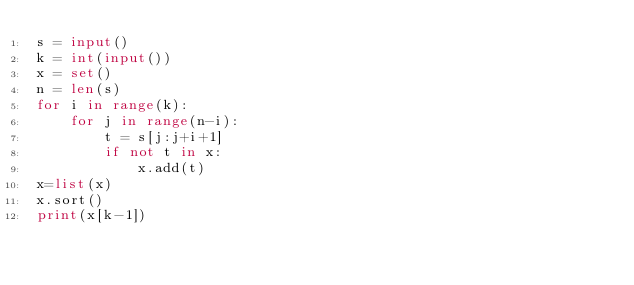<code> <loc_0><loc_0><loc_500><loc_500><_Python_>s = input()
k = int(input())
x = set()
n = len(s)
for i in range(k):
    for j in range(n-i):
        t = s[j:j+i+1]
        if not t in x:
            x.add(t)
x=list(x)
x.sort()
print(x[k-1])</code> 